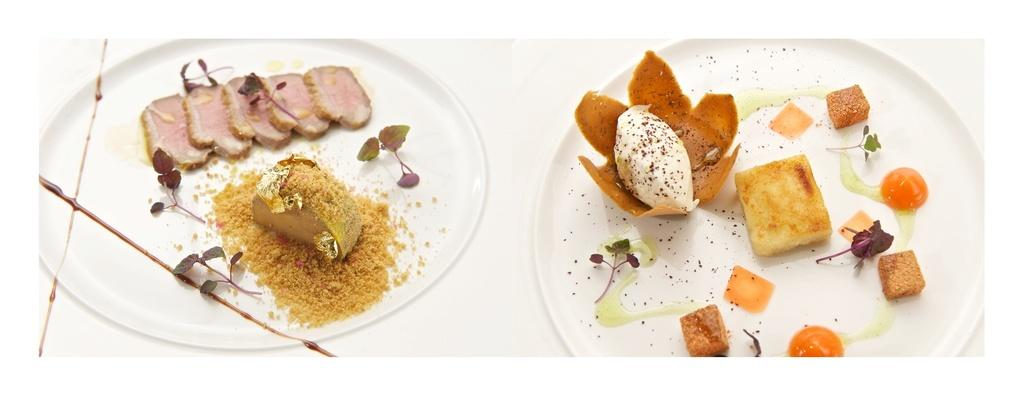What is present on the plates in the image? There is food in the plates in the image. What type of air can be seen in the picture? There is no air visible in the image, as it is a still picture. What type of family can be seen in the image? There is no family present in the image; it only shows food on plates. 